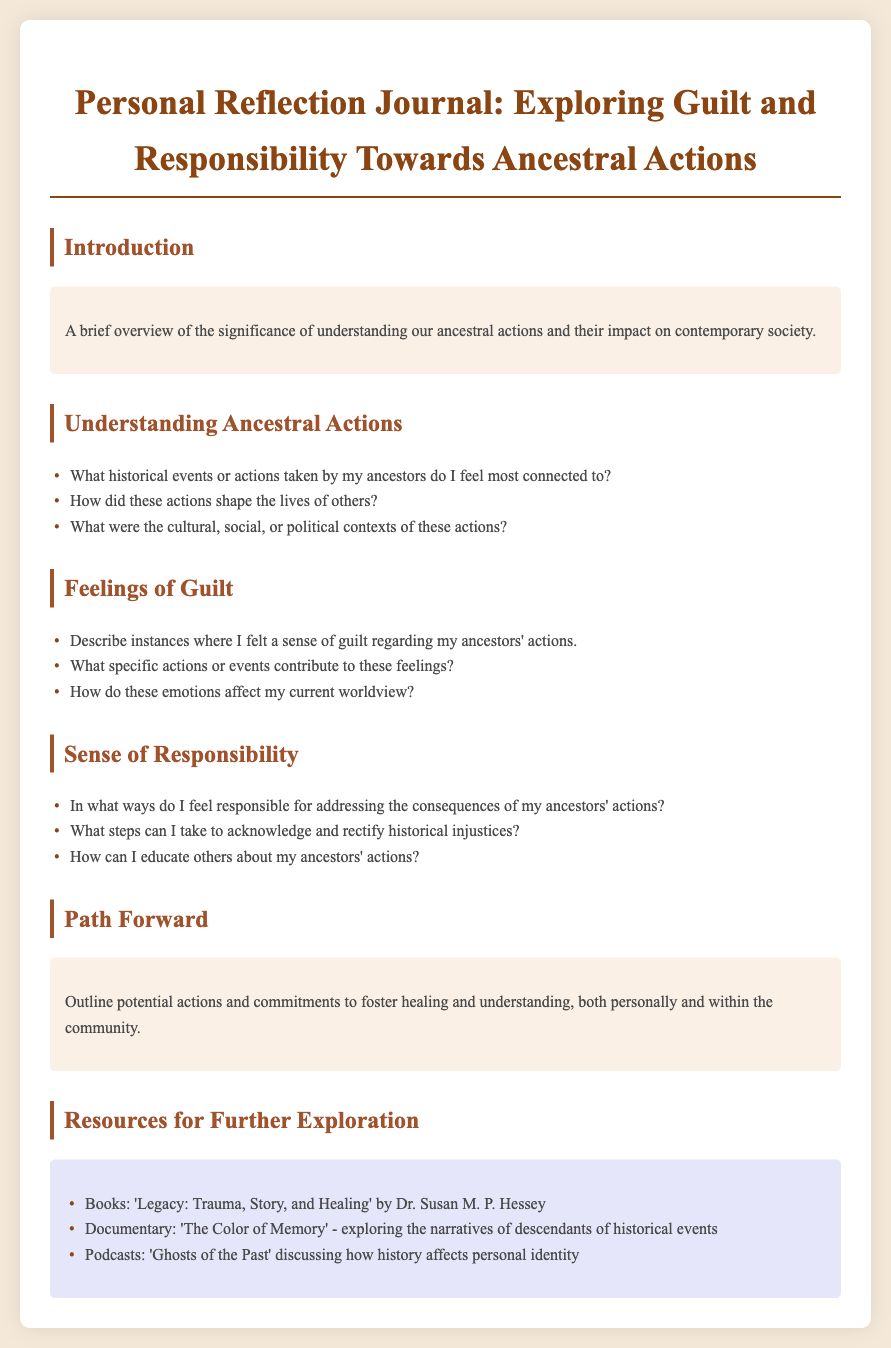What is the title of the document? The title is presented in the header as a part of the document structure.
Answer: Personal Reflection Journal: Exploring Guilt and Responsibility Towards Ancestral Actions What is one resource recommended for further exploration? The resources section lists various materials for deeper understanding.
Answer: 'Legacy: Trauma, Story, and Healing' by Dr. Susan M. P. Hessey Which section discusses feelings of guilt? The sections are numbered and titled, with the specific focus on emotions highlighted.
Answer: Feelings of Guilt What is one question regarding ancestral actions? The document lists specific prompts under the Understanding Ancestral Actions section.
Answer: What historical events or actions taken by my ancestors do I feel most connected to? How does the document encourage readers to engage with their feelings? It includes sections focused on emotions, responsibilities, and proposed actions, suggesting introspection.
Answer: Through personal reflection and exploration of guilt What color is used for the document's background? The background color is specified in the style rules for the document.
Answer: #f4e9d9 What are potential actions mentioned in the Path Forward section? The section outlines actions for healing and understanding, which are part of personal development.
Answer: Outline potential actions and commitments Who might the podcast 'Ghosts of the Past' appeal to? The title indicates a focus on historical narratives affecting identity, which is relevant to those exploring ancestry.
Answer: Descendants of historical events 